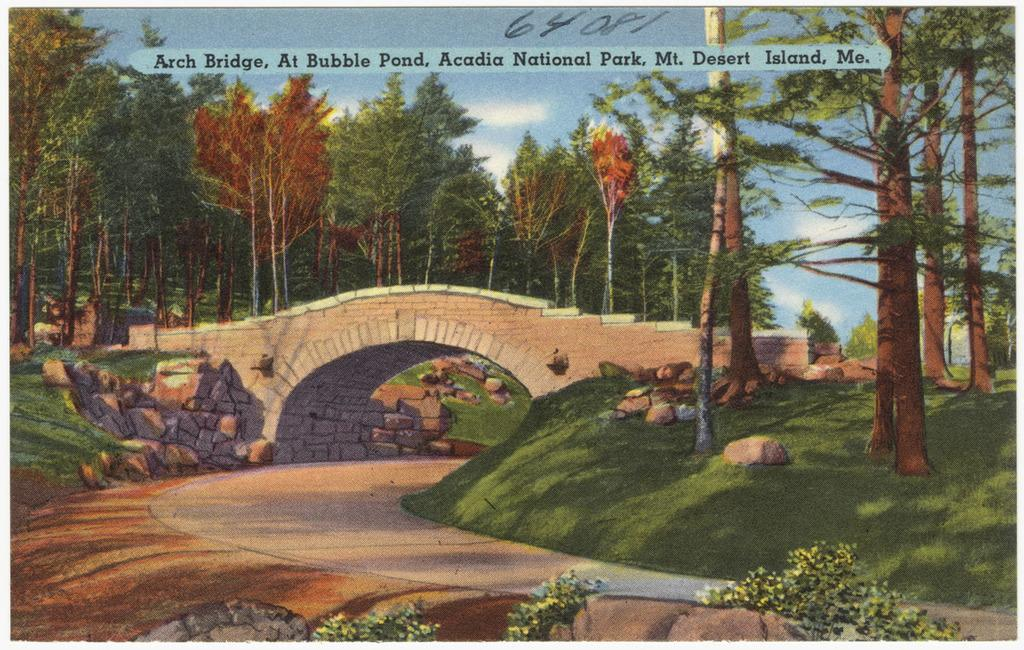What is the main subject of the image? There is a painting in the image. What elements are included in the painting? The painting contains trees, a bridge, and rocks. Is there any text present in the image? Yes, there is text written at the top of the image. Can you tell me how many books are on the trail in the image? There is no trail or books present in the image; it features a painting with trees, a bridge, and rocks. 